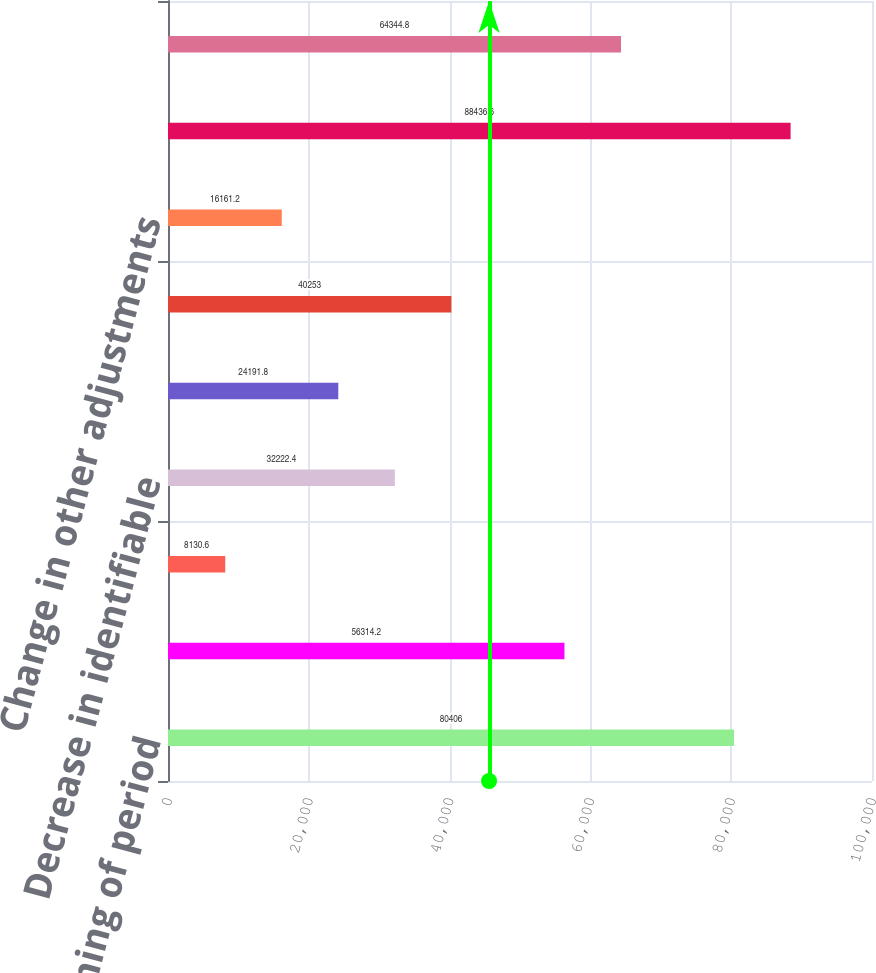<chart> <loc_0><loc_0><loc_500><loc_500><bar_chart><fcel>Balance beginning of period<fcel>Increase in common<fcel>(Increase)/decrease in<fcel>Decrease in identifiable<fcel>(Increase)/decrease in equity<fcel>Change in debt valuation<fcel>Change in other adjustments<fcel>Balance end of period<fcel>Net increase in Tier 1 common<nl><fcel>80406<fcel>56314.2<fcel>8130.6<fcel>32222.4<fcel>24191.8<fcel>40253<fcel>16161.2<fcel>88436.6<fcel>64344.8<nl></chart> 